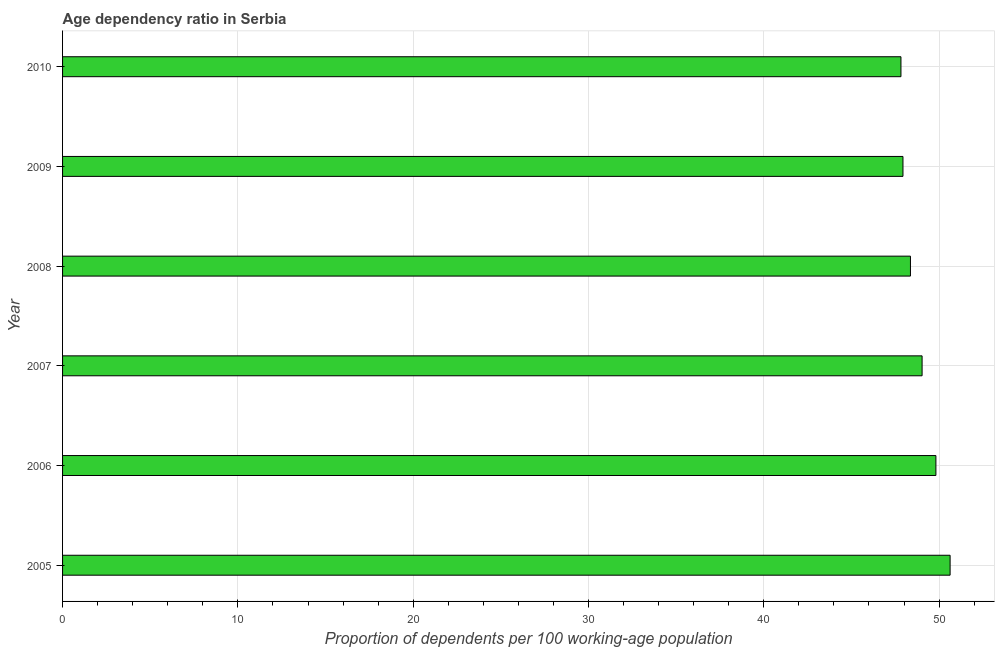Does the graph contain grids?
Your answer should be compact. Yes. What is the title of the graph?
Make the answer very short. Age dependency ratio in Serbia. What is the label or title of the X-axis?
Make the answer very short. Proportion of dependents per 100 working-age population. What is the label or title of the Y-axis?
Ensure brevity in your answer.  Year. What is the age dependency ratio in 2010?
Offer a terse response. 47.82. Across all years, what is the maximum age dependency ratio?
Provide a short and direct response. 50.63. Across all years, what is the minimum age dependency ratio?
Your answer should be compact. 47.82. In which year was the age dependency ratio minimum?
Ensure brevity in your answer.  2010. What is the sum of the age dependency ratio?
Provide a short and direct response. 293.6. What is the difference between the age dependency ratio in 2008 and 2010?
Ensure brevity in your answer.  0.54. What is the average age dependency ratio per year?
Keep it short and to the point. 48.93. What is the median age dependency ratio?
Your answer should be compact. 48.7. In how many years, is the age dependency ratio greater than 10 ?
Offer a terse response. 6. Do a majority of the years between 2007 and 2005 (inclusive) have age dependency ratio greater than 8 ?
Keep it short and to the point. Yes. Is the age dependency ratio in 2007 less than that in 2009?
Keep it short and to the point. No. What is the difference between the highest and the second highest age dependency ratio?
Provide a short and direct response. 0.81. What is the difference between the highest and the lowest age dependency ratio?
Provide a short and direct response. 2.8. In how many years, is the age dependency ratio greater than the average age dependency ratio taken over all years?
Your response must be concise. 3. How many years are there in the graph?
Give a very brief answer. 6. What is the difference between two consecutive major ticks on the X-axis?
Keep it short and to the point. 10. Are the values on the major ticks of X-axis written in scientific E-notation?
Provide a short and direct response. No. What is the Proportion of dependents per 100 working-age population of 2005?
Your response must be concise. 50.63. What is the Proportion of dependents per 100 working-age population in 2006?
Your response must be concise. 49.82. What is the Proportion of dependents per 100 working-age population of 2007?
Give a very brief answer. 49.03. What is the Proportion of dependents per 100 working-age population in 2008?
Give a very brief answer. 48.36. What is the Proportion of dependents per 100 working-age population of 2009?
Make the answer very short. 47.94. What is the Proportion of dependents per 100 working-age population of 2010?
Make the answer very short. 47.82. What is the difference between the Proportion of dependents per 100 working-age population in 2005 and 2006?
Keep it short and to the point. 0.81. What is the difference between the Proportion of dependents per 100 working-age population in 2005 and 2007?
Offer a terse response. 1.6. What is the difference between the Proportion of dependents per 100 working-age population in 2005 and 2008?
Provide a short and direct response. 2.26. What is the difference between the Proportion of dependents per 100 working-age population in 2005 and 2009?
Make the answer very short. 2.69. What is the difference between the Proportion of dependents per 100 working-age population in 2005 and 2010?
Make the answer very short. 2.8. What is the difference between the Proportion of dependents per 100 working-age population in 2006 and 2007?
Your answer should be very brief. 0.79. What is the difference between the Proportion of dependents per 100 working-age population in 2006 and 2008?
Give a very brief answer. 1.45. What is the difference between the Proportion of dependents per 100 working-age population in 2006 and 2009?
Give a very brief answer. 1.88. What is the difference between the Proportion of dependents per 100 working-age population in 2006 and 2010?
Ensure brevity in your answer.  1.99. What is the difference between the Proportion of dependents per 100 working-age population in 2007 and 2008?
Provide a short and direct response. 0.66. What is the difference between the Proportion of dependents per 100 working-age population in 2007 and 2009?
Offer a very short reply. 1.09. What is the difference between the Proportion of dependents per 100 working-age population in 2007 and 2010?
Make the answer very short. 1.21. What is the difference between the Proportion of dependents per 100 working-age population in 2008 and 2009?
Your response must be concise. 0.43. What is the difference between the Proportion of dependents per 100 working-age population in 2008 and 2010?
Provide a succinct answer. 0.54. What is the difference between the Proportion of dependents per 100 working-age population in 2009 and 2010?
Keep it short and to the point. 0.12. What is the ratio of the Proportion of dependents per 100 working-age population in 2005 to that in 2007?
Give a very brief answer. 1.03. What is the ratio of the Proportion of dependents per 100 working-age population in 2005 to that in 2008?
Ensure brevity in your answer.  1.05. What is the ratio of the Proportion of dependents per 100 working-age population in 2005 to that in 2009?
Provide a succinct answer. 1.06. What is the ratio of the Proportion of dependents per 100 working-age population in 2005 to that in 2010?
Your answer should be very brief. 1.06. What is the ratio of the Proportion of dependents per 100 working-age population in 2006 to that in 2007?
Ensure brevity in your answer.  1.02. What is the ratio of the Proportion of dependents per 100 working-age population in 2006 to that in 2008?
Make the answer very short. 1.03. What is the ratio of the Proportion of dependents per 100 working-age population in 2006 to that in 2009?
Your answer should be very brief. 1.04. What is the ratio of the Proportion of dependents per 100 working-age population in 2006 to that in 2010?
Provide a short and direct response. 1.04. What is the ratio of the Proportion of dependents per 100 working-age population in 2007 to that in 2009?
Make the answer very short. 1.02. What is the ratio of the Proportion of dependents per 100 working-age population in 2007 to that in 2010?
Your answer should be compact. 1.02. What is the ratio of the Proportion of dependents per 100 working-age population in 2008 to that in 2009?
Make the answer very short. 1.01. What is the ratio of the Proportion of dependents per 100 working-age population in 2009 to that in 2010?
Give a very brief answer. 1. 